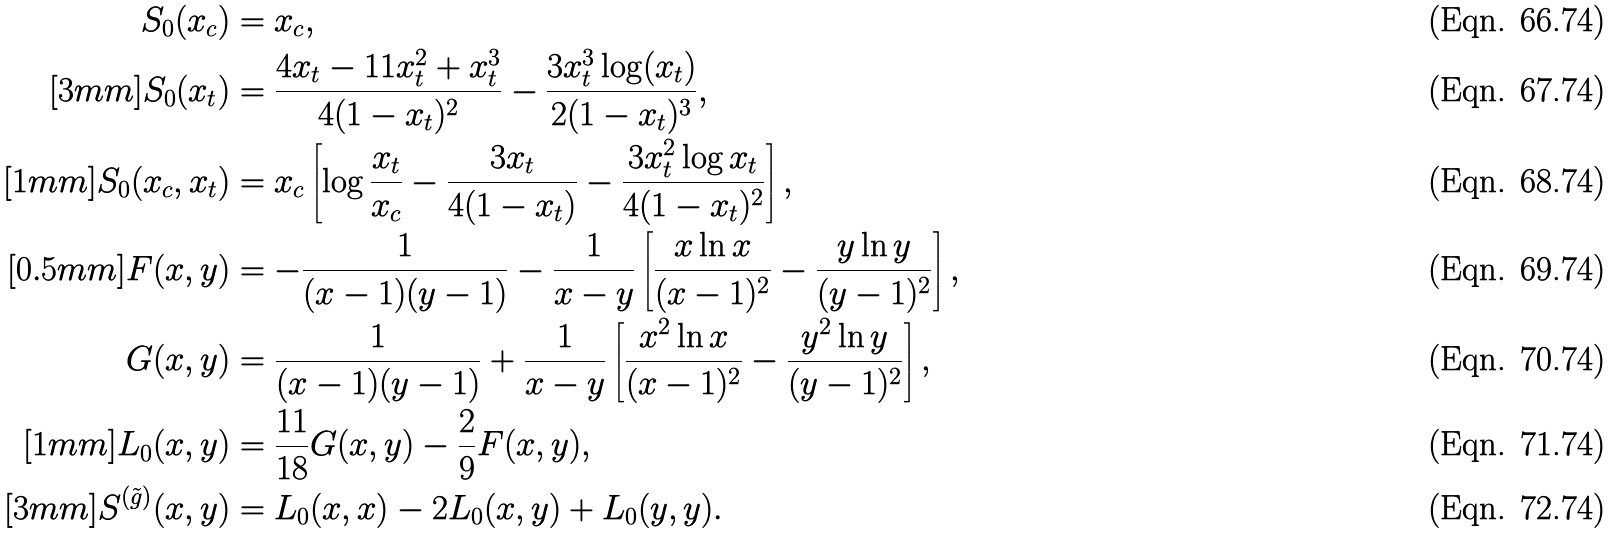<formula> <loc_0><loc_0><loc_500><loc_500>S _ { 0 } ( x _ { c } ) & = x _ { c } , \\ [ 3 m m ] S _ { 0 } ( x _ { t } ) & = \frac { 4 x _ { t } - 1 1 x _ { t } ^ { 2 } + x _ { t } ^ { 3 } } { 4 ( 1 - x _ { t } ) ^ { 2 } } - \frac { 3 x _ { t } ^ { 3 } \log ( x _ { t } ) } { 2 ( 1 - x _ { t } ) ^ { 3 } } , \\ [ 1 m m ] S _ { 0 } ( x _ { c } , x _ { t } ) & = x _ { c } \left [ \log \frac { x _ { t } } { x _ { c } } - \frac { 3 x _ { t } } { 4 ( 1 - x _ { t } ) } - \frac { 3 x _ { t } ^ { 2 } \log x _ { t } } { 4 ( 1 - x _ { t } ) ^ { 2 } } \right ] , \\ [ 0 . 5 m m ] F ( x , y ) & = - \frac { 1 } { ( x - 1 ) ( y - 1 ) } - \frac { 1 } { x - y } \left [ \frac { x \ln x } { ( x - 1 ) ^ { 2 } } - \frac { y \ln y } { ( y - 1 ) ^ { 2 } } \right ] , \\ G ( x , y ) & = \frac { 1 } { ( x - 1 ) ( y - 1 ) } + \frac { 1 } { x - y } \left [ \frac { x ^ { 2 } \ln x } { ( x - 1 ) ^ { 2 } } - \frac { y ^ { 2 } \ln y } { ( y - 1 ) ^ { 2 } } \right ] , \\ [ 1 m m ] L _ { 0 } ( x , y ) & = \frac { 1 1 } { 1 8 } G ( x , y ) - \frac { 2 } { 9 } F ( x , y ) , \\ [ 3 m m ] S ^ { ( \tilde { g } ) } ( x , y ) & = L _ { 0 } ( x , x ) - 2 L _ { 0 } ( x , y ) + L _ { 0 } ( y , y ) .</formula> 